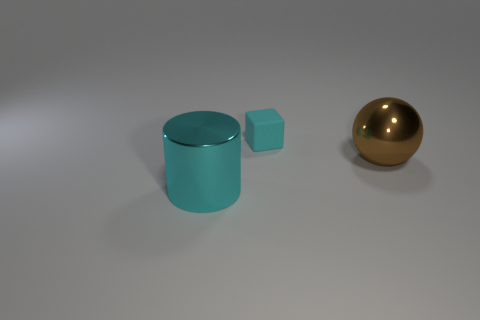Subtract 1 balls. How many balls are left? 0 Add 2 big red matte blocks. How many big red matte blocks exist? 2 Add 3 large brown metallic spheres. How many objects exist? 6 Subtract 1 cyan cubes. How many objects are left? 2 Subtract all cubes. How many objects are left? 2 Subtract all big red metal cubes. Subtract all large cyan metal objects. How many objects are left? 2 Add 1 big cyan cylinders. How many big cyan cylinders are left? 2 